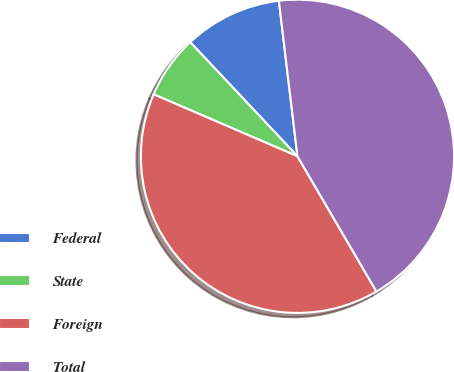Convert chart. <chart><loc_0><loc_0><loc_500><loc_500><pie_chart><fcel>Federal<fcel>State<fcel>Foreign<fcel>Total<nl><fcel>10.11%<fcel>6.52%<fcel>39.89%<fcel>43.48%<nl></chart> 